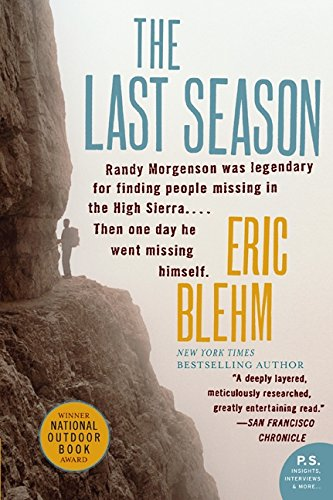Who wrote this book?
Answer the question using a single word or phrase. Eric Blehm What is the title of this book? The Last Season (P.S.) What type of book is this? Business & Money Is this a financial book? Yes Is this a comedy book? No 